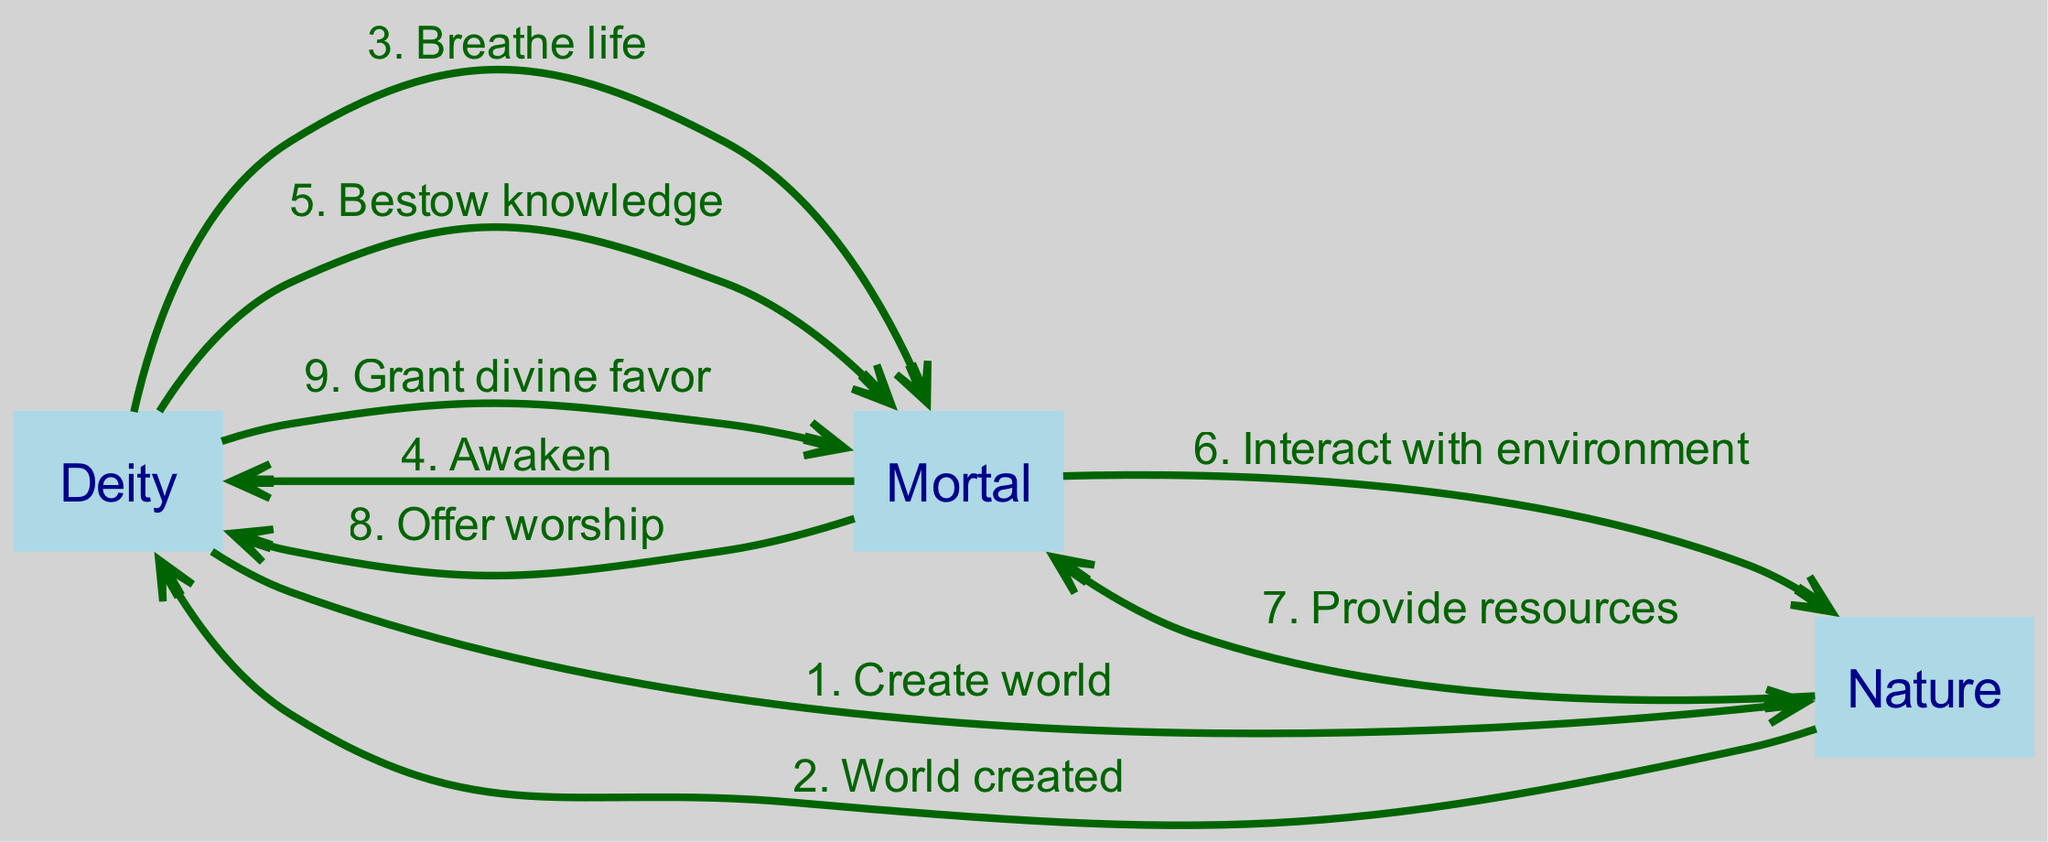What are the three main actors in this diagram? The diagram lists three actors: Deity, Mortal, and Nature, which are shown as nodes in the sequence diagram.
Answer: Deity, Mortal, Nature How many interactions are shown in total? By counting the number of edges (interactions) present in the diagram, we see there are eight distinct interactions listed.
Answer: 8 What is the first interaction that occurs in the sequence? The first interaction in the sequence is from Deity to Nature, with the message "Create world," as it represents the beginning of the creation process.
Answer: Create world Which actor receives the message "Provide resources"? The interaction labeled "Provide resources" is sent from Nature to Mortal, indicating that Nature provides resources to the Mortal for living in the created world.
Answer: Mortal What happens after the Mortal interacts with Nature? After the Mortal interacts with Nature, the next interaction is from Nature to Mortal, providing resources. This highlights a cycle of interaction between the Mortal and Nature, emphasizing their relationship.
Answer: Provide resources What is the last interaction shown in the diagram? The final interaction in the diagram is "Grant divine favor," which is sent from Deity to Mortal, signaling a blessing or support from the divine to the created being.
Answer: Grant divine favor How many messages are sent from Deity to Mortal? Counting the interactions shows that there are three messages from Deity to Mortal: "Breathe life," "Bestow knowledge," and "Grant divine favor."
Answer: 3 What role does Nature play after the world is created? After the world is created, Nature plays the role of providing resources to the Mortal, underscoring the support from the environment to the human beings that inhabit it.
Answer: Provide resources 